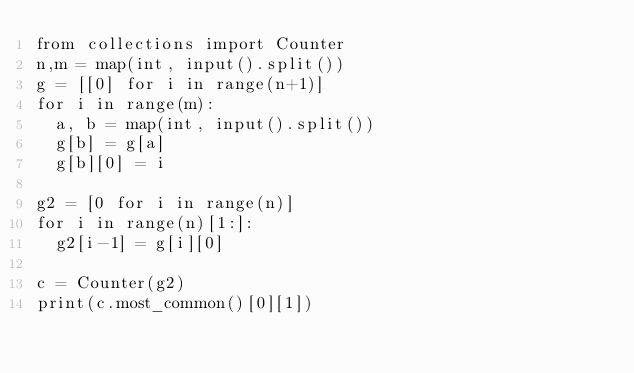<code> <loc_0><loc_0><loc_500><loc_500><_Python_>from collections import Counter
n,m = map(int, input().split())
g = [[0] for i in range(n+1)]
for i in range(m):
  a, b = map(int, input().split())
  g[b] = g[a]
  g[b][0] = i
  
g2 = [0 for i in range(n)]
for i in range(n)[1:]:
  g2[i-1] = g[i][0]
  
c = Counter(g2)
print(c.most_common()[0][1])</code> 